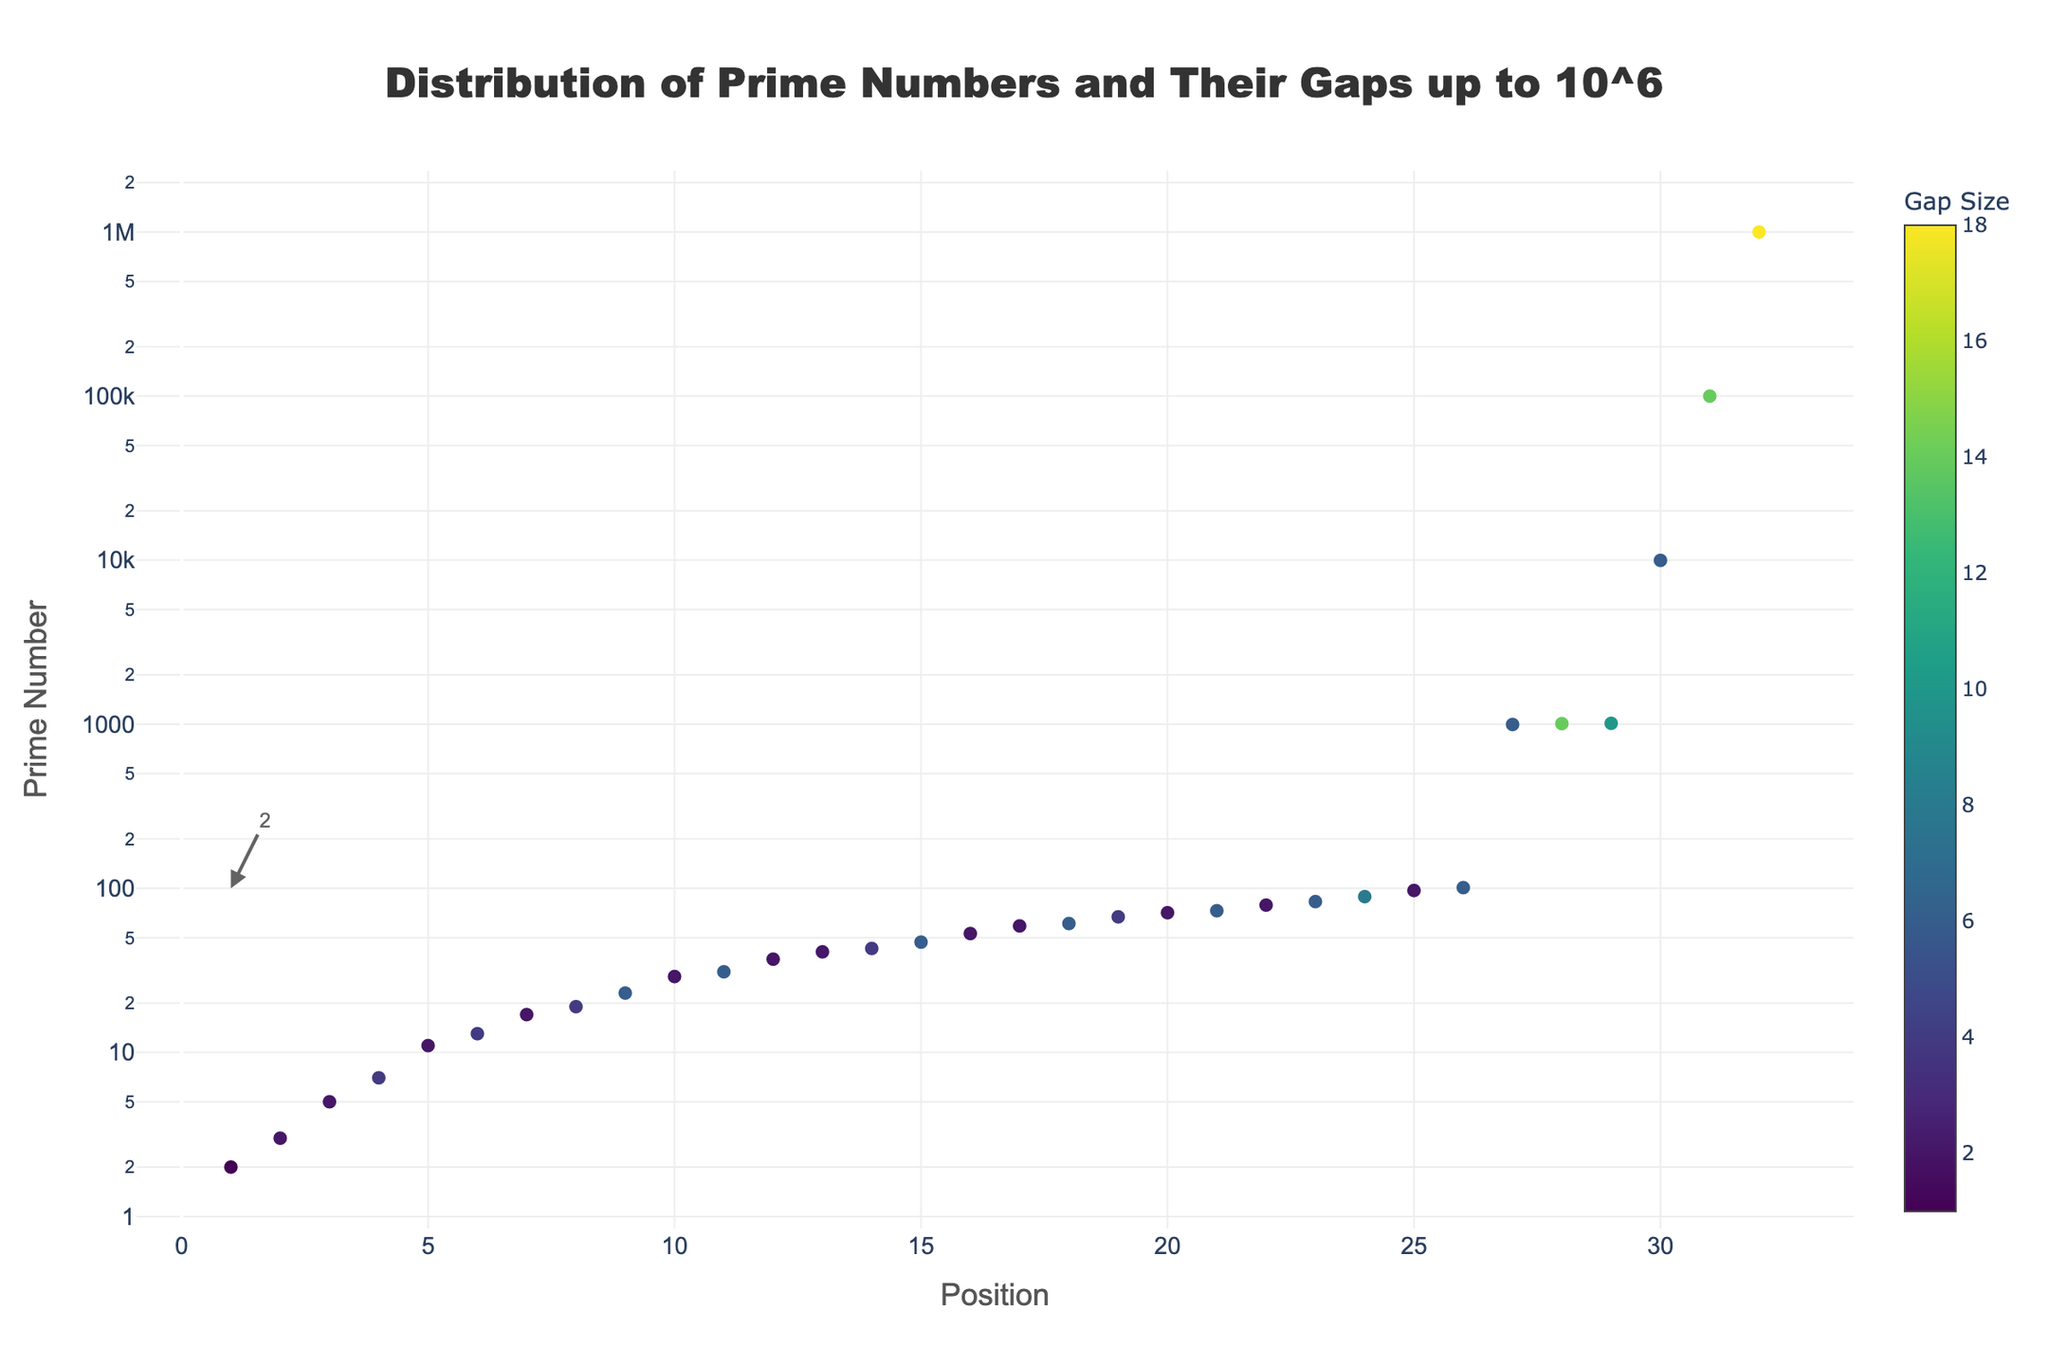What's the title of the figure? The title of the figure is generally placed at the top and is straightforward to read. It's intended to summarize the main topic of the plot.
Answer: Distribution of Prime Numbers and Their Gaps up to 10^6 What's the range of the x-axis? The x-axis typically represents the position of the data points, which starts from 0 on the left. By looking at the x-axis closely, the range of values can be determined.
Answer: 1 to 32 What does the color scale represent in the plot? The color scale on the plot, usually shown alongside the data points, indicates a specific variable. By observing the color bar, we can determine what it represents in relation to the data points.
Answer: Gap Size Which prime number is highlighted as the largest under 10000? Annotations in the plot often highlight specific data points with text. These annotations can help identify key primes.
Answer: 9973 How are twin primes visually differentiated from other primes in the figure? By examining the description tags and the color scale, along with the markers positioned close to each other, the nature of the data points can be inferred.
Answer: Twin primes have smaller gap sizes, indicated by a particular color What is the prime number at position 20 and its associated gap size? By tracing the position on the x-axis to a specific y-value and possibly referring to the hover text, the prime number and its corresponding gap size can be found.
Answer: Prime number 71, Gap size 2 Between positions 10 and 12 (inclusive), which prime number has the smallest gap size? This involves comparing the gap sizes of the prime numbers at these positions by examining the specific color differences or size gradients on the plot.
Answer: Prime number 31 (Gap size 2) How does the gap size change as the primes get larger, specifically around position 28 and above? By observing the trend in the color and size of the markers around these positions, any change in the gap size can be identified.
Answer: The gap size increases significantly, as indicated by the color shift to higher values What is the pattern note associated with the prime number 999983? The hover text provided at each prime number marker gives details about the pattern note; by locating this prime, we can read the associated text.
Answer: Largest prime under 1000000 What is the general trend of prime number values as we move from position 1 to position 32 on the x-axis? By examining the y-axis values from left to right, a general pattern or trend for the growth of prime numbers can be discerned.
Answer: Prime numbers generally increase exponentially 